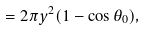Convert formula to latex. <formula><loc_0><loc_0><loc_500><loc_500>= 2 \pi y ^ { 2 } ( 1 - \cos \theta _ { 0 } ) ,</formula> 